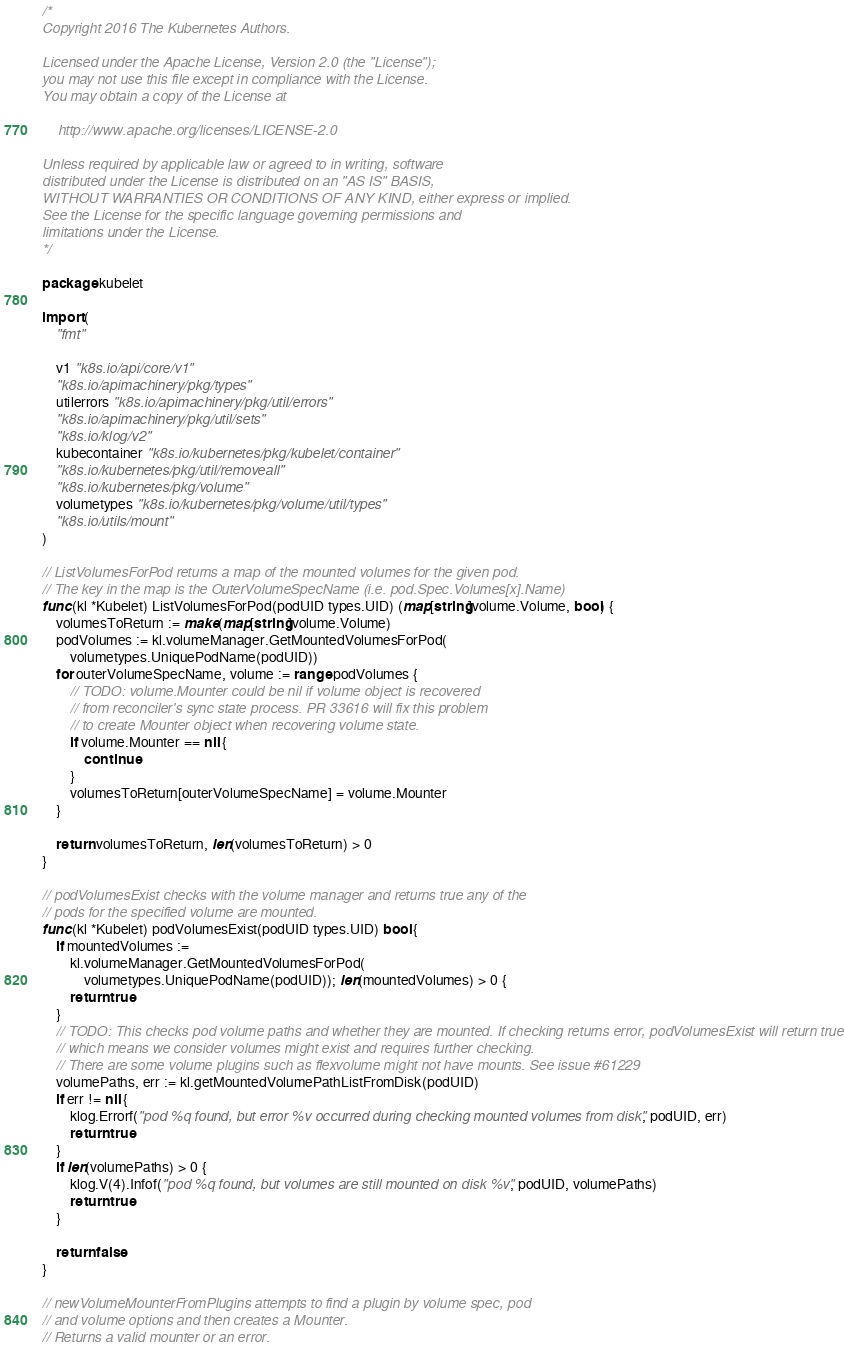Convert code to text. <code><loc_0><loc_0><loc_500><loc_500><_Go_>/*
Copyright 2016 The Kubernetes Authors.

Licensed under the Apache License, Version 2.0 (the "License");
you may not use this file except in compliance with the License.
You may obtain a copy of the License at

    http://www.apache.org/licenses/LICENSE-2.0

Unless required by applicable law or agreed to in writing, software
distributed under the License is distributed on an "AS IS" BASIS,
WITHOUT WARRANTIES OR CONDITIONS OF ANY KIND, either express or implied.
See the License for the specific language governing permissions and
limitations under the License.
*/

package kubelet

import (
	"fmt"

	v1 "k8s.io/api/core/v1"
	"k8s.io/apimachinery/pkg/types"
	utilerrors "k8s.io/apimachinery/pkg/util/errors"
	"k8s.io/apimachinery/pkg/util/sets"
	"k8s.io/klog/v2"
	kubecontainer "k8s.io/kubernetes/pkg/kubelet/container"
	"k8s.io/kubernetes/pkg/util/removeall"
	"k8s.io/kubernetes/pkg/volume"
	volumetypes "k8s.io/kubernetes/pkg/volume/util/types"
	"k8s.io/utils/mount"
)

// ListVolumesForPod returns a map of the mounted volumes for the given pod.
// The key in the map is the OuterVolumeSpecName (i.e. pod.Spec.Volumes[x].Name)
func (kl *Kubelet) ListVolumesForPod(podUID types.UID) (map[string]volume.Volume, bool) {
	volumesToReturn := make(map[string]volume.Volume)
	podVolumes := kl.volumeManager.GetMountedVolumesForPod(
		volumetypes.UniquePodName(podUID))
	for outerVolumeSpecName, volume := range podVolumes {
		// TODO: volume.Mounter could be nil if volume object is recovered
		// from reconciler's sync state process. PR 33616 will fix this problem
		// to create Mounter object when recovering volume state.
		if volume.Mounter == nil {
			continue
		}
		volumesToReturn[outerVolumeSpecName] = volume.Mounter
	}

	return volumesToReturn, len(volumesToReturn) > 0
}

// podVolumesExist checks with the volume manager and returns true any of the
// pods for the specified volume are mounted.
func (kl *Kubelet) podVolumesExist(podUID types.UID) bool {
	if mountedVolumes :=
		kl.volumeManager.GetMountedVolumesForPod(
			volumetypes.UniquePodName(podUID)); len(mountedVolumes) > 0 {
		return true
	}
	// TODO: This checks pod volume paths and whether they are mounted. If checking returns error, podVolumesExist will return true
	// which means we consider volumes might exist and requires further checking.
	// There are some volume plugins such as flexvolume might not have mounts. See issue #61229
	volumePaths, err := kl.getMountedVolumePathListFromDisk(podUID)
	if err != nil {
		klog.Errorf("pod %q found, but error %v occurred during checking mounted volumes from disk", podUID, err)
		return true
	}
	if len(volumePaths) > 0 {
		klog.V(4).Infof("pod %q found, but volumes are still mounted on disk %v", podUID, volumePaths)
		return true
	}

	return false
}

// newVolumeMounterFromPlugins attempts to find a plugin by volume spec, pod
// and volume options and then creates a Mounter.
// Returns a valid mounter or an error.</code> 